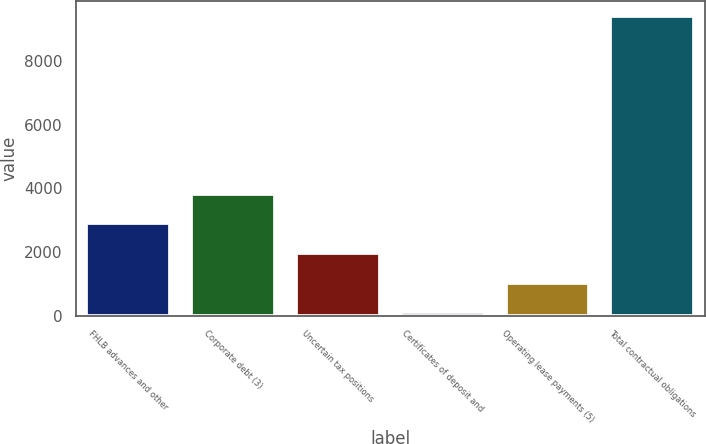<chart> <loc_0><loc_0><loc_500><loc_500><bar_chart><fcel>FHLB advances and other<fcel>Corporate debt (3)<fcel>Uncertain tax positions<fcel>Certificates of deposit and<fcel>Operating lease payments (5)<fcel>Total contractual obligations<nl><fcel>2899.37<fcel>3829.26<fcel>1969.48<fcel>109.7<fcel>1039.59<fcel>9408.6<nl></chart> 